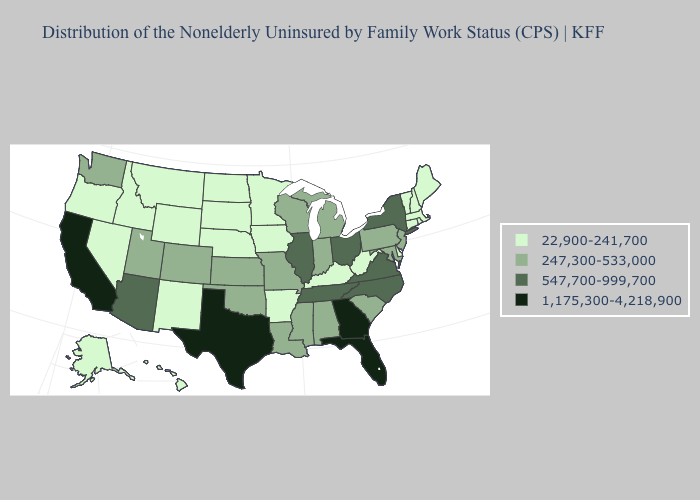What is the value of Connecticut?
Quick response, please. 22,900-241,700. Which states have the lowest value in the MidWest?
Concise answer only. Iowa, Minnesota, Nebraska, North Dakota, South Dakota. What is the highest value in states that border Tennessee?
Be succinct. 1,175,300-4,218,900. Which states have the lowest value in the South?
Quick response, please. Arkansas, Delaware, Kentucky, West Virginia. Is the legend a continuous bar?
Write a very short answer. No. What is the lowest value in the West?
Short answer required. 22,900-241,700. Does the first symbol in the legend represent the smallest category?
Concise answer only. Yes. What is the highest value in the South ?
Keep it brief. 1,175,300-4,218,900. Name the states that have a value in the range 22,900-241,700?
Short answer required. Alaska, Arkansas, Connecticut, Delaware, Hawaii, Idaho, Iowa, Kentucky, Maine, Massachusetts, Minnesota, Montana, Nebraska, Nevada, New Hampshire, New Mexico, North Dakota, Oregon, Rhode Island, South Dakota, Vermont, West Virginia, Wyoming. What is the lowest value in the USA?
Give a very brief answer. 22,900-241,700. Name the states that have a value in the range 247,300-533,000?
Give a very brief answer. Alabama, Colorado, Indiana, Kansas, Louisiana, Maryland, Michigan, Mississippi, Missouri, New Jersey, Oklahoma, Pennsylvania, South Carolina, Utah, Washington, Wisconsin. What is the value of Connecticut?
Be succinct. 22,900-241,700. Among the states that border Louisiana , which have the lowest value?
Answer briefly. Arkansas. Which states have the highest value in the USA?
Answer briefly. California, Florida, Georgia, Texas. How many symbols are there in the legend?
Concise answer only. 4. 